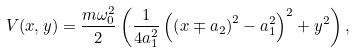<formula> <loc_0><loc_0><loc_500><loc_500>V ( x , y ) = \frac { m \omega _ { 0 } ^ { 2 } } { 2 } \left ( \frac { 1 } { 4 a _ { 1 } ^ { 2 } } \left ( \left ( x \mp a _ { 2 } \right ) ^ { 2 } - a _ { 1 } ^ { 2 } \right ) ^ { 2 } + y ^ { 2 } \right ) ,</formula> 